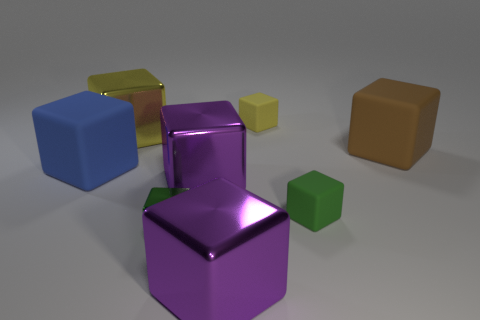The small rubber object that is the same color as the small shiny object is what shape?
Your answer should be compact. Cube. What is the material of the cube that is the same color as the small metallic thing?
Your answer should be very brief. Rubber. How many other objects are there of the same color as the tiny metallic thing?
Offer a very short reply. 1. How many tiny blue rubber cylinders are there?
Keep it short and to the point. 0. There is a small thing behind the thing on the left side of the yellow metal thing; what is it made of?
Provide a short and direct response. Rubber. There is a blue thing that is the same size as the brown rubber object; what material is it?
Provide a succinct answer. Rubber. There is a rubber thing in front of the blue matte object; does it have the same size as the small metallic cube?
Your answer should be compact. Yes. There is a large object that is left of the yellow shiny block; is it the same shape as the big yellow metallic thing?
Keep it short and to the point. Yes. What number of things are either large red rubber spheres or yellow blocks that are right of the tiny metallic cube?
Offer a very short reply. 1. Are there fewer things than red cylinders?
Make the answer very short. No. 